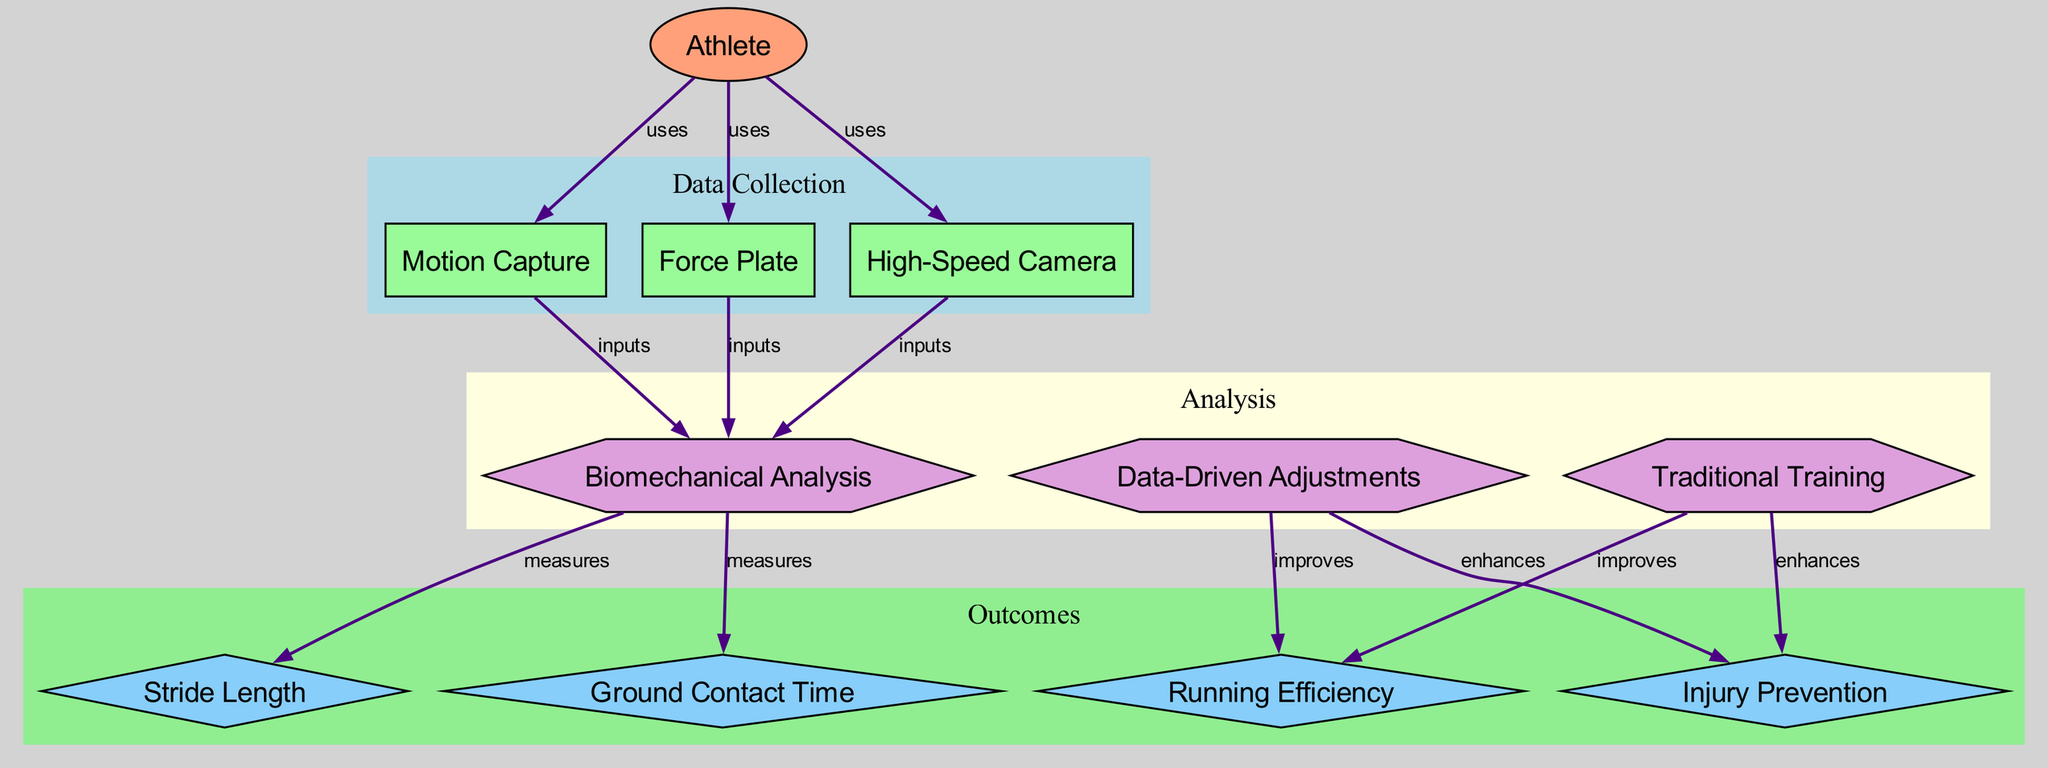What technologies does the athlete use for biomechanical analysis? The diagram shows three technologies that the athlete uses: motion capture, force plate, and high-speed camera. These technologies are all connected to the athlete node with 'uses' labels that indicate their role in data collection for biomechanical analysis.
Answer: motion capture, force plate, high-speed camera How many metrics are measured through biomechanical analysis? The diagram illustrates two metrics derived from biomechanical analysis: stride length and ground contact time. These metrics are directly connected to the biomechanical analysis node with 'measures' labels.
Answer: two What process aims to improve running efficiency? The diagram shows two processes that can improve running efficiency: data-driven adjustments and traditional training. Both processes are connected to the running efficiency metric with 'improves' relationships.
Answer: data-driven adjustments, traditional training What enhances injury prevention, according to the diagram? The diagram indicates that both data-driven adjustments and traditional training enhance injury prevention. These processes are linked to the injury prevention metric with 'enhances' labels.
Answer: data-driven adjustments, traditional training Which technology specifically provides input for biomechanical analysis? All three technologies listed—motion capture, force plate, and high-speed camera—provide input for biomechanical analysis. Each technology is connected to the biomechanical analysis process with 'inputs' labels in the diagram.
Answer: motion capture, force plate, high-speed camera What are the two outcomes measured in the biomechanical analysis process? The diagram specifies that the outcomes measured through the biomechanical analysis process are running efficiency and injury prevention. These metrics are connected to the biomechanical analysis node with different edges labeled accordingly.
Answer: running efficiency, injury prevention Explain how data-driven adjustments improve running efficiency. The diagram illustrates that data-driven adjustments are a process that directly improves running efficiency. This is evidenced by their linkage in the diagram, where data-driven adjustments have an 'improves' relationship with the running efficiency metric, indicating a positive influence.
Answer: data-driven adjustments Which process has a direct correlation with stride length? The diagram shows that stride length is a metric that is specifically measured as a result of biomechanical analysis. Therefore, the process that has a direct correlation with stride length is biomechanical analysis itself, since it is linked to this metric with a 'measures' relationship.
Answer: biomechanical analysis What is the relationship between traditional training and injury prevention? According to the diagram, traditional training enhances injury prevention. This relationship is represented by an 'enhances' label on the edge connecting traditional training to the injury prevention metric, indicating that traditional training contributes positively to this outcome.
Answer: enhances 